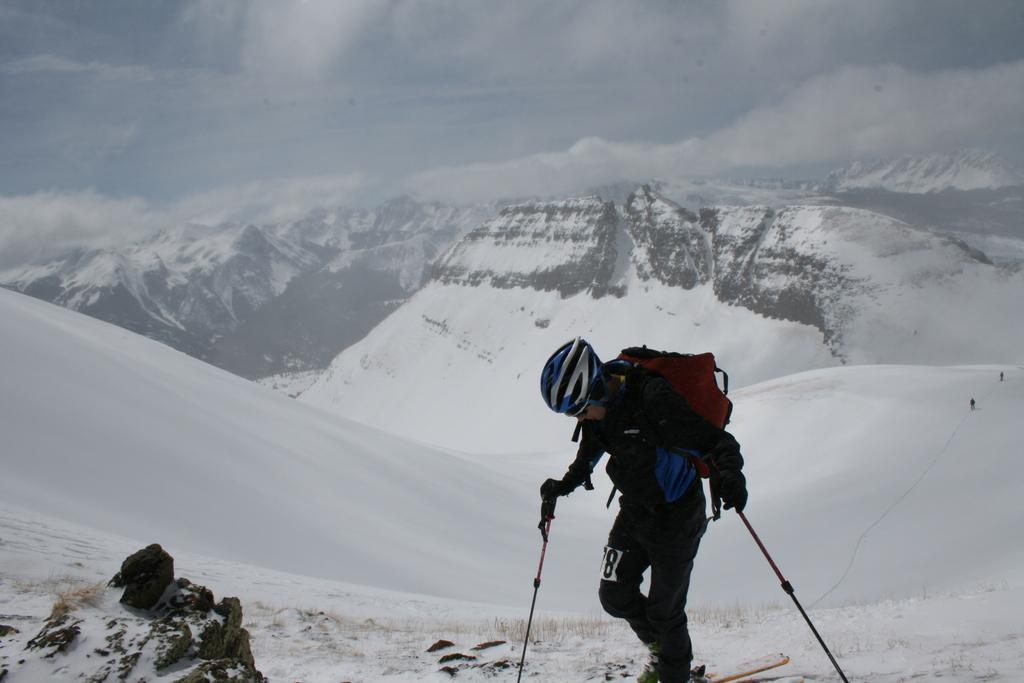What is the man in the image doing? The man is skating in the image. What is the man holding while skating? The man is holding sticks in the image. What type of terrain can be seen in the image? There are hills visible in the image. What is the weather like in the image? There is snow in the image, and clouds are visible in the sky. What part of the natural environment is visible in the image? The sky is visible at the top of the image. What type of writing can be seen on the donkey in the image? There is no donkey present in the image, and therefore no writing can be seen on it. 